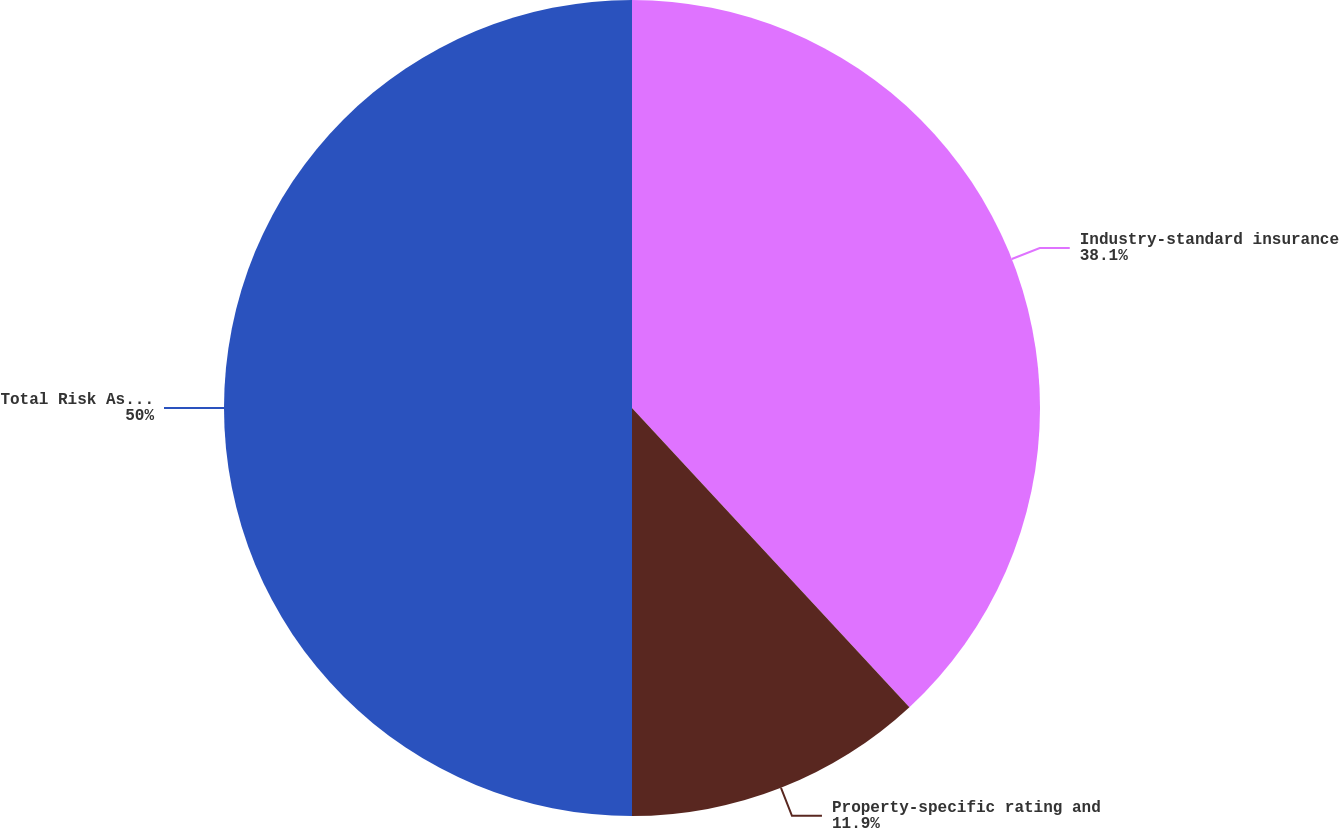Convert chart to OTSL. <chart><loc_0><loc_0><loc_500><loc_500><pie_chart><fcel>Industry-standard insurance<fcel>Property-specific rating and<fcel>Total Risk Assessment<nl><fcel>38.1%<fcel>11.9%<fcel>50.0%<nl></chart> 